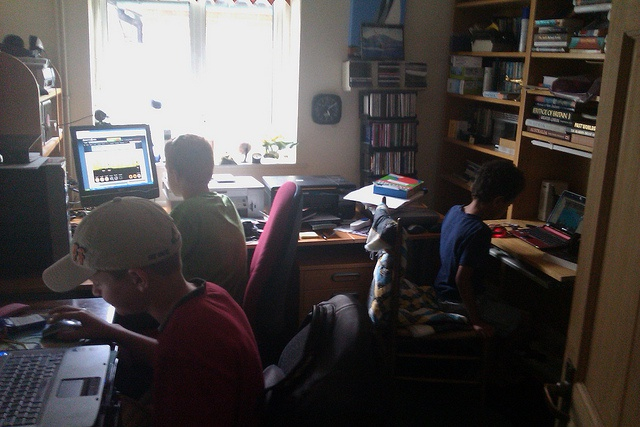Describe the objects in this image and their specific colors. I can see people in gray, black, maroon, and purple tones, chair in gray, black, darkgray, and lightgray tones, people in gray, black, navy, darkblue, and purple tones, chair in gray and black tones, and people in gray, black, and darkgray tones in this image. 